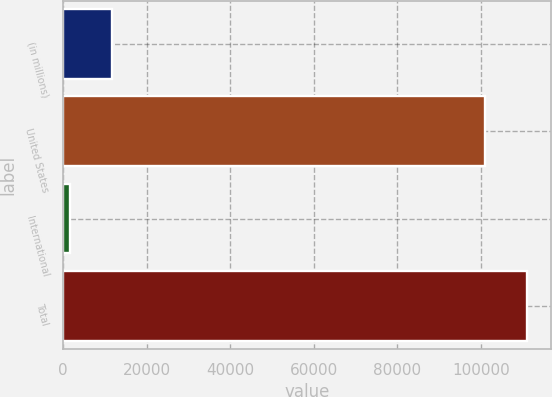Convert chart. <chart><loc_0><loc_0><loc_500><loc_500><bar_chart><fcel>(in millions)<fcel>United States<fcel>International<fcel>Total<nl><fcel>11672<fcel>101080<fcel>1564<fcel>111188<nl></chart> 